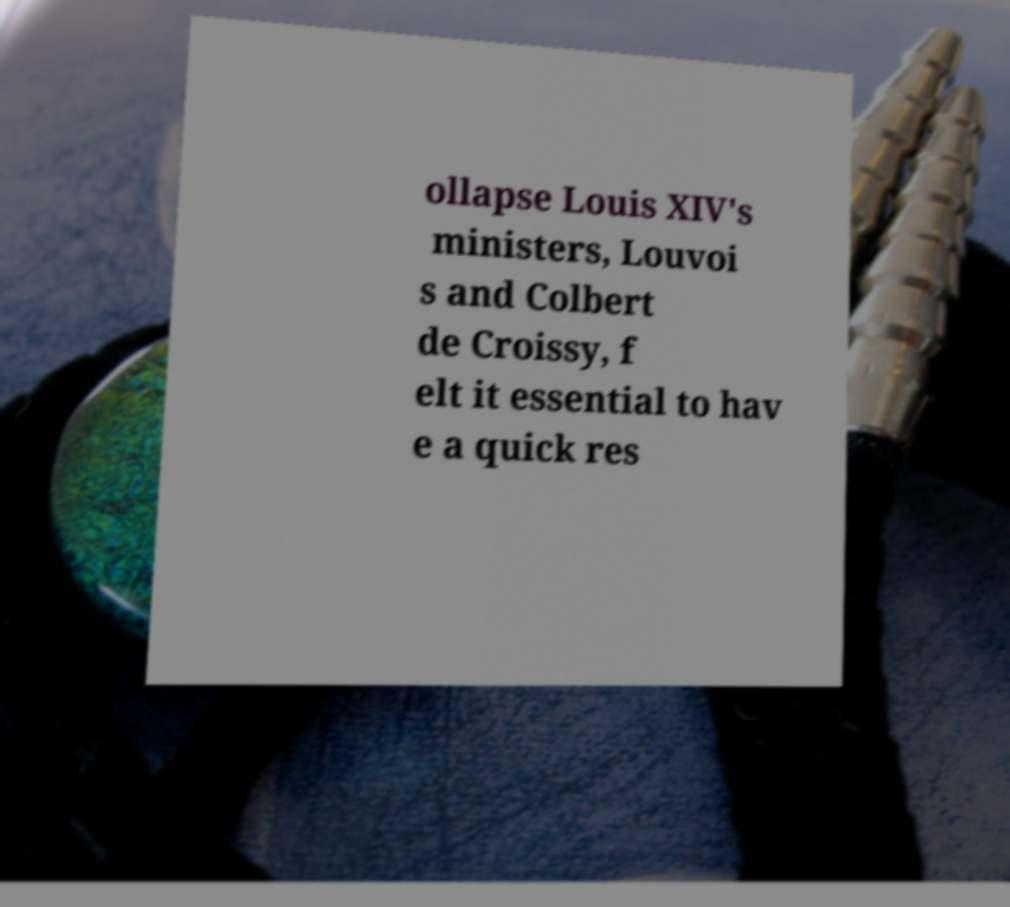Please read and relay the text visible in this image. What does it say? ollapse Louis XIV's ministers, Louvoi s and Colbert de Croissy, f elt it essential to hav e a quick res 